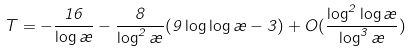Convert formula to latex. <formula><loc_0><loc_0><loc_500><loc_500>T = - \frac { 1 6 } { \log \rho } - \frac { 8 } { \log ^ { 2 } \rho } ( 9 \log \log \rho - 3 ) + O ( \frac { \log ^ { 2 } \log \rho } { \log ^ { 3 } \rho } )</formula> 